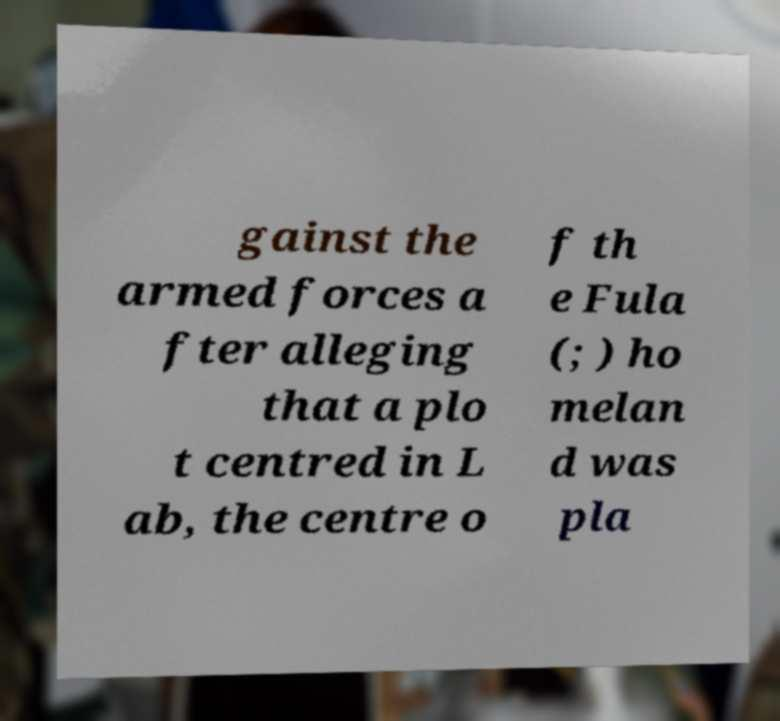Could you extract and type out the text from this image? gainst the armed forces a fter alleging that a plo t centred in L ab, the centre o f th e Fula (; ) ho melan d was pla 